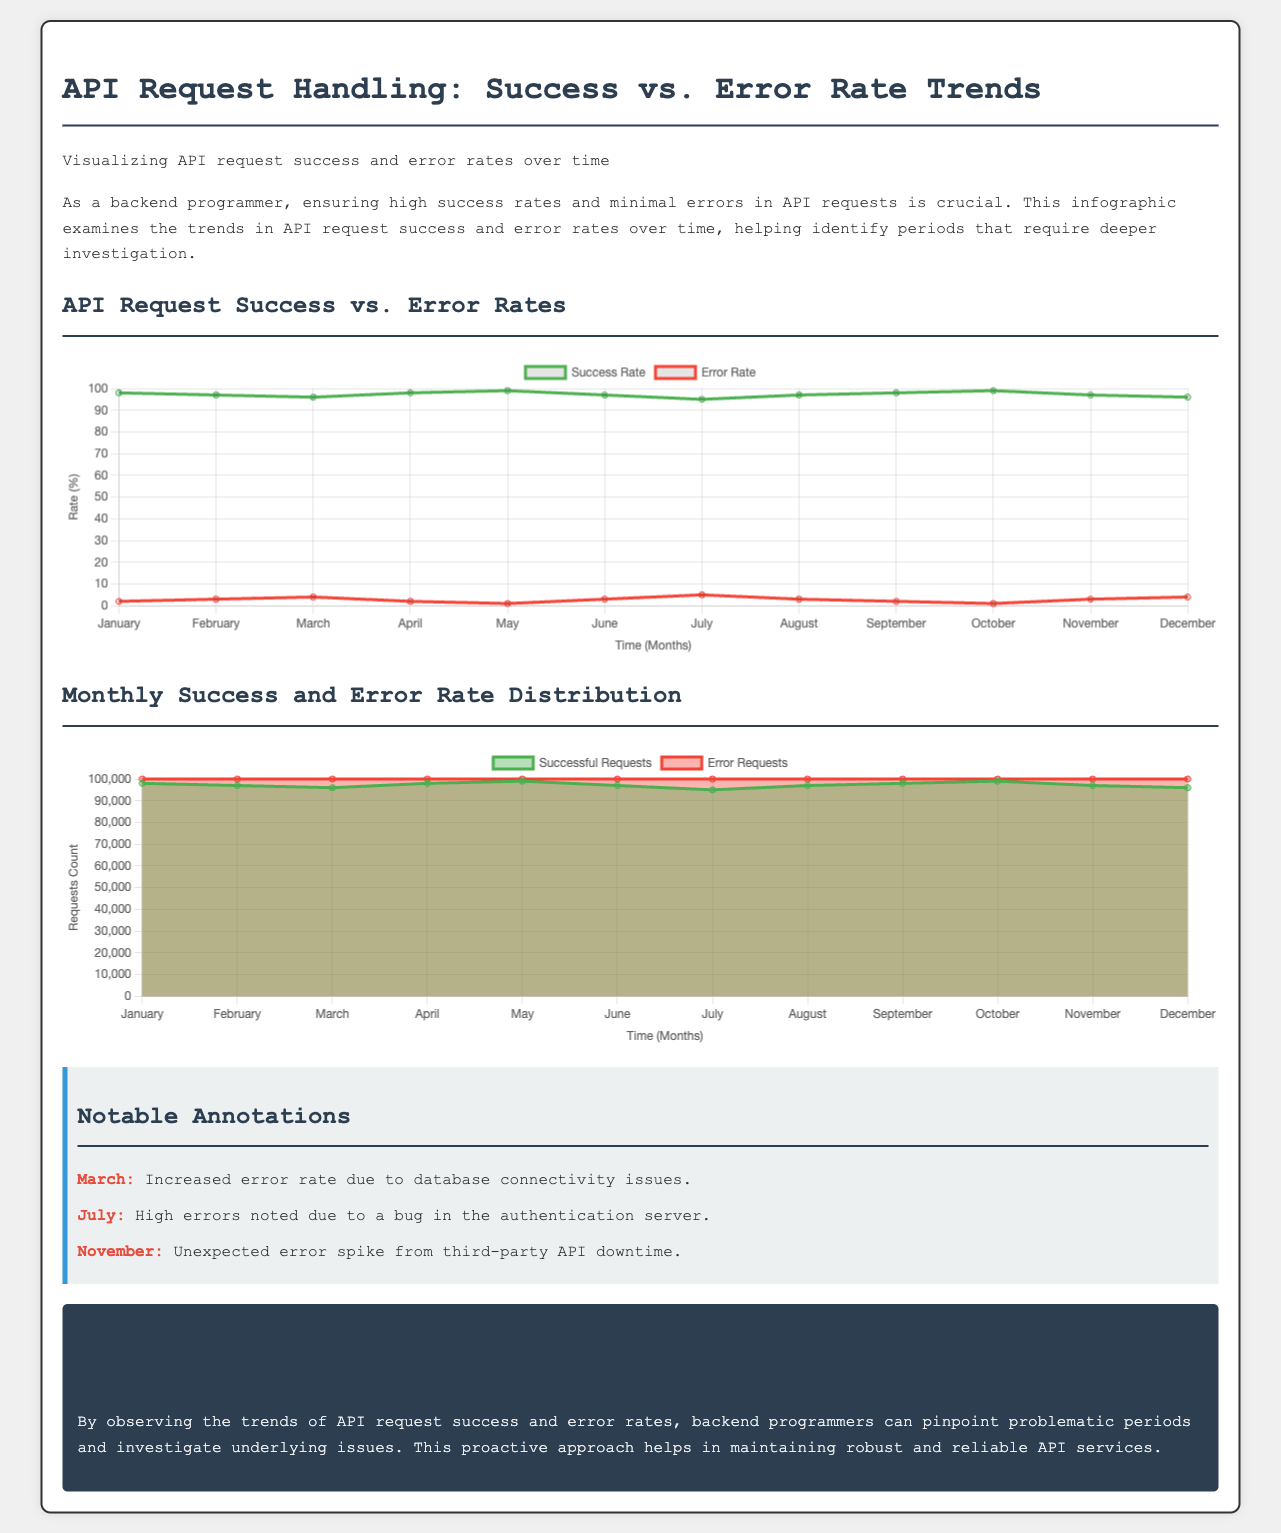what was the success rate in February? The success rate for February is directly listed in the document's data for that month.
Answer: 97 what is the error rate in July? The error rate for July is specified in the document as part of the dataset for that month.
Answer: 5 what is highlighted as the cause of increased errors in March? The document contains an annotation that discusses the reason for increased errors during March.
Answer: database connectivity issues which month experienced a bug in the authentication server? The infographic highlights July as the month with this specific issue.
Answer: July what type of chart is used to display monthly success and error rates? The document indicates the specific type of chart used for this information.
Answer: area chart which month had the highest error requests? The document specifies the number of error requests for each month, allowing determination of the highest month.
Answer: July what percentage of API requests were successful in November? The success rate for November is calculated from the data provided in the document.
Answer: 97 what does the conclusion suggest programmers can achieve by monitoring trends? The conclusion summarizes a potential benefit of observing trends indicated in the infographic.
Answer: maintain robust and reliable API services how many successful requests were there in April? The document includes specific data regarding the number of successful requests for that month.
Answer: 98000 